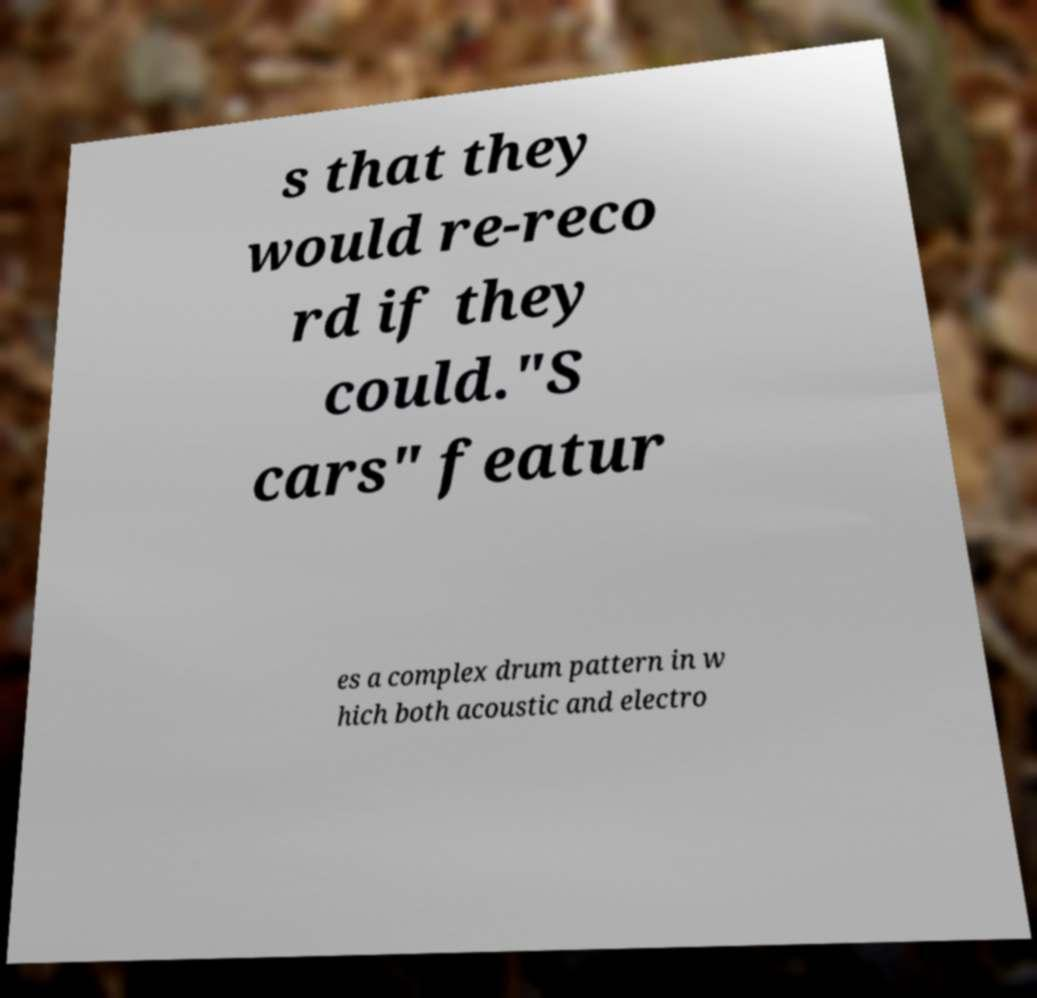What messages or text are displayed in this image? I need them in a readable, typed format. s that they would re-reco rd if they could."S cars" featur es a complex drum pattern in w hich both acoustic and electro 